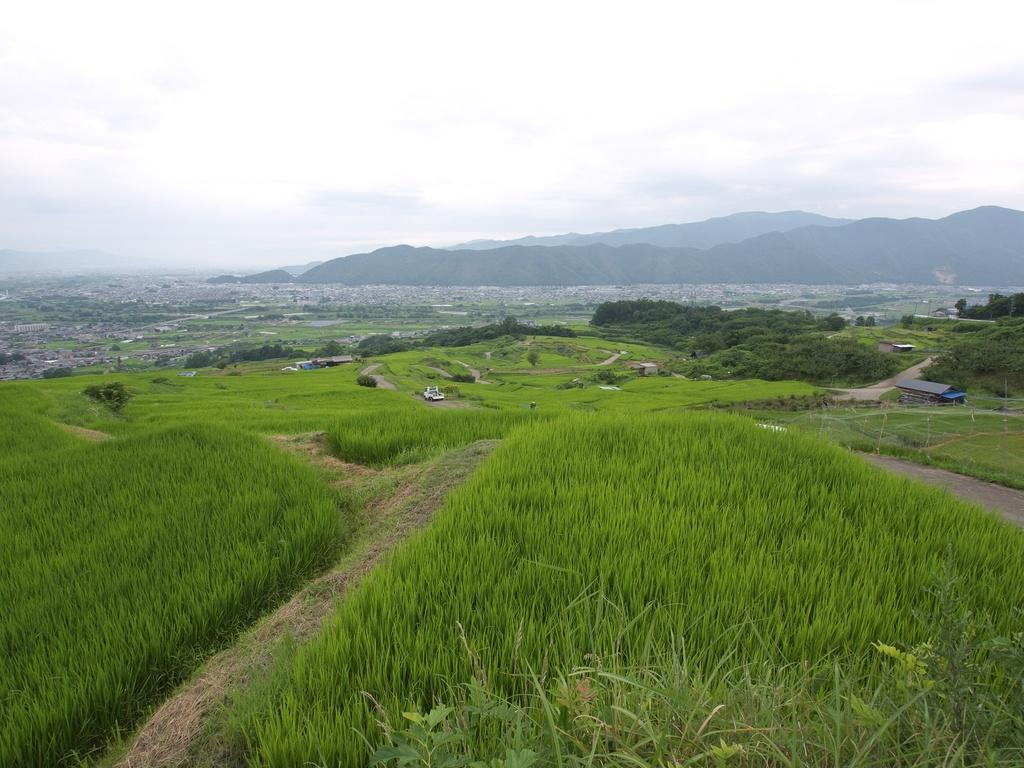What type of vegetation can be seen in the image? There is grass in the image. What type of structures are present in the image? There are houses in the image. What other natural elements can be seen in the image? There are trees in the image. What geographical features are visible in the image? There are hills in the image. Is there an ice trail visible in the image? There is no ice or trail present in the image. What type of connection can be seen between the houses in the image? There is no visible connection between the houses in the image. 